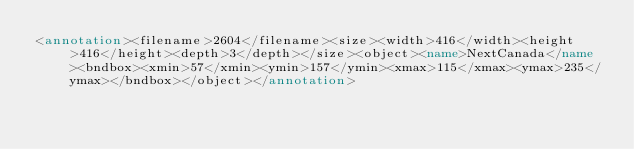<code> <loc_0><loc_0><loc_500><loc_500><_XML_><annotation><filename>2604</filename><size><width>416</width><height>416</height><depth>3</depth></size><object><name>NextCanada</name><bndbox><xmin>57</xmin><ymin>157</ymin><xmax>115</xmax><ymax>235</ymax></bndbox></object></annotation></code> 